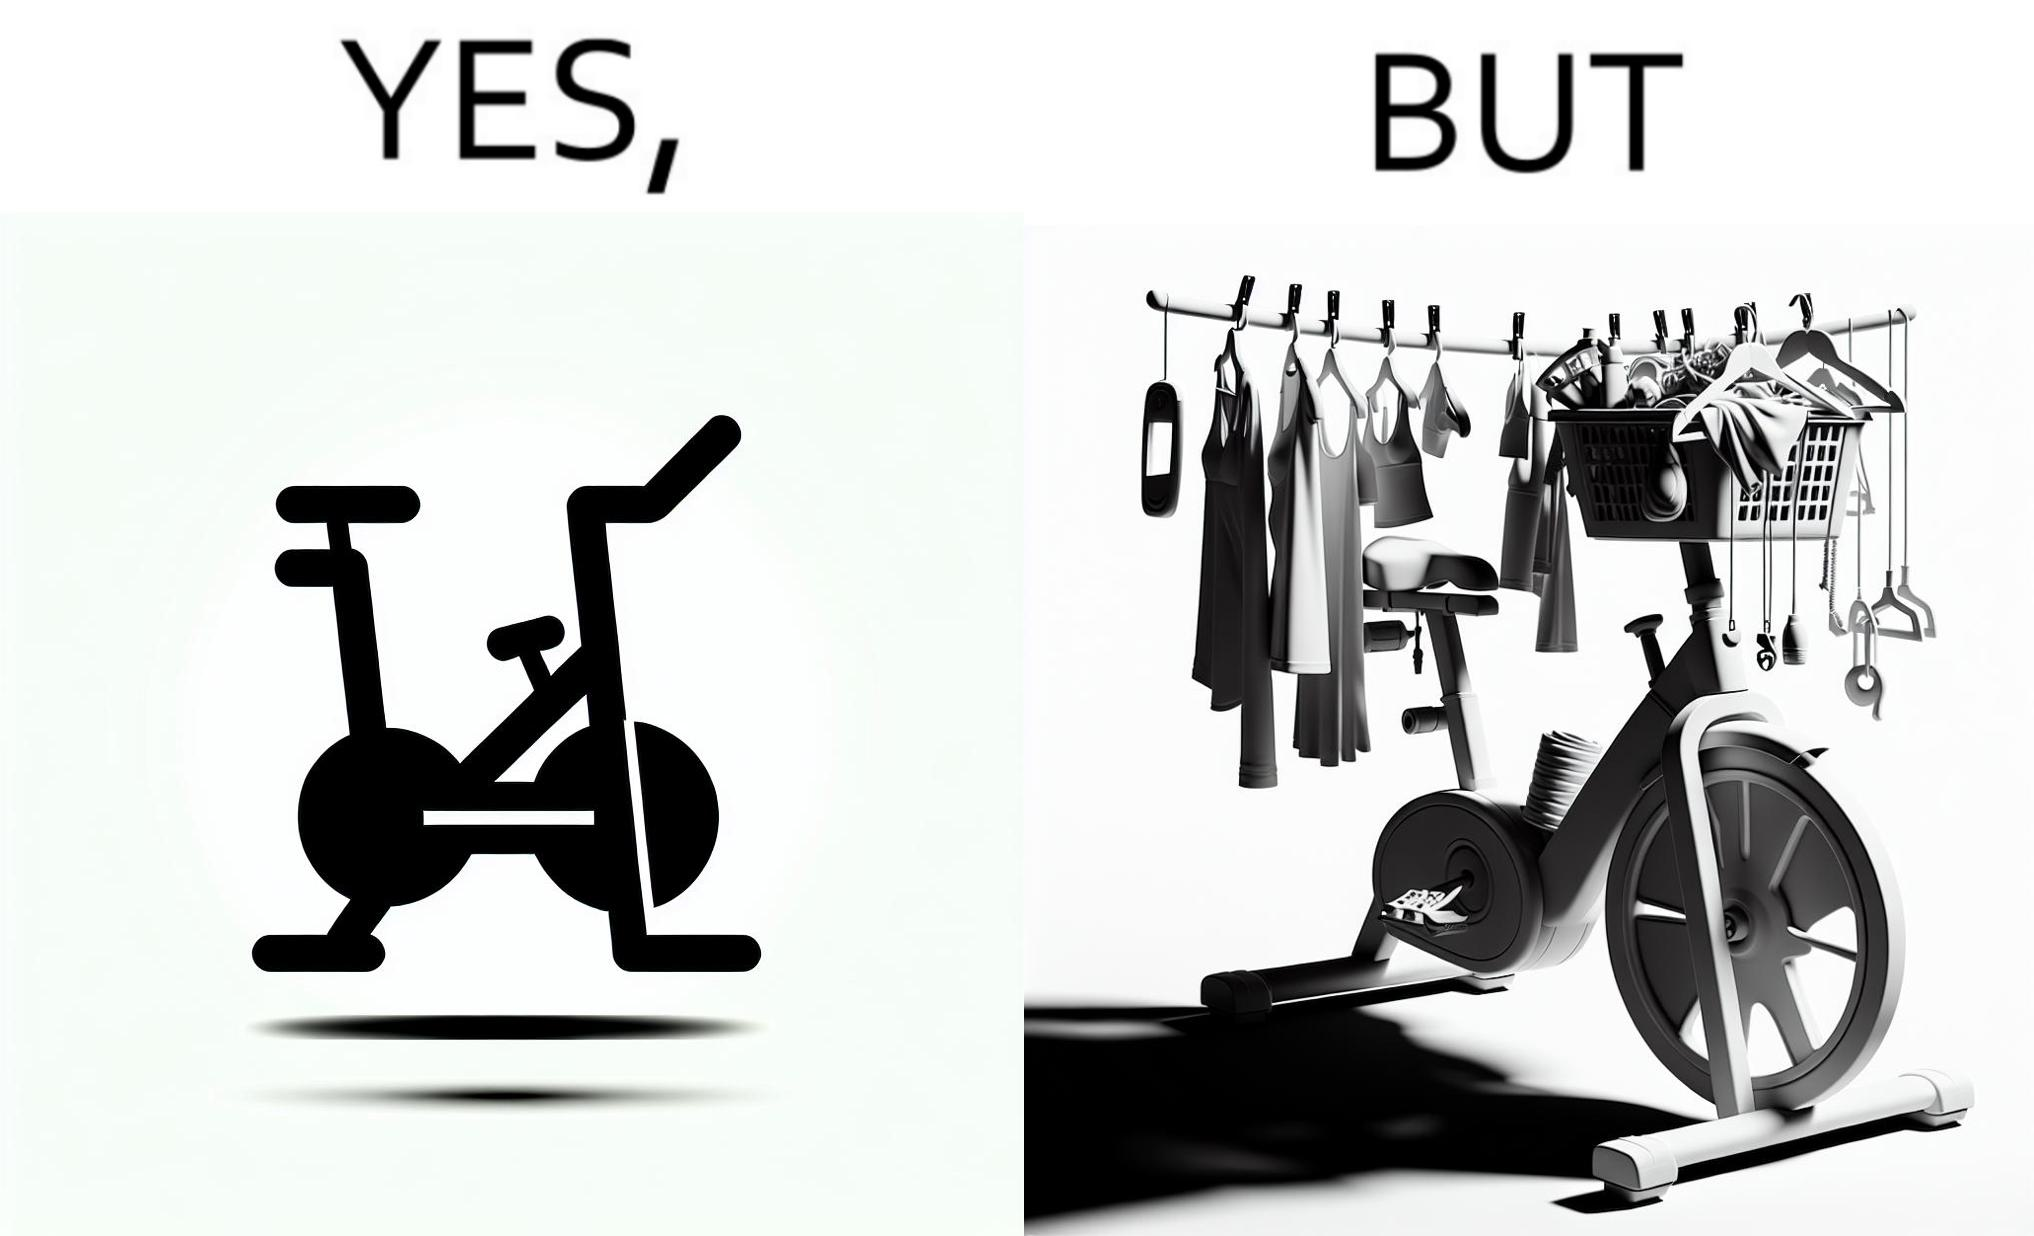Explain the humor or irony in this image. The images are funny since they show an exercise bike has been bought but is not being used for its purpose, that is, exercising. It is rather being used to hang clothes, bags and other items 